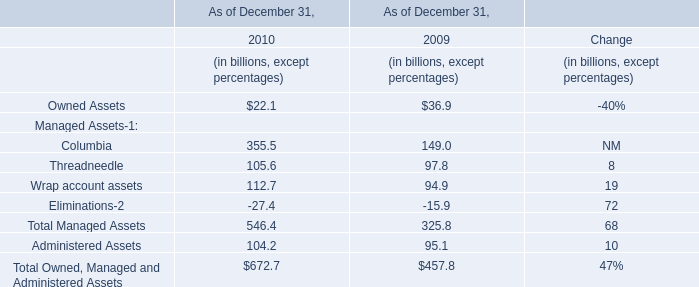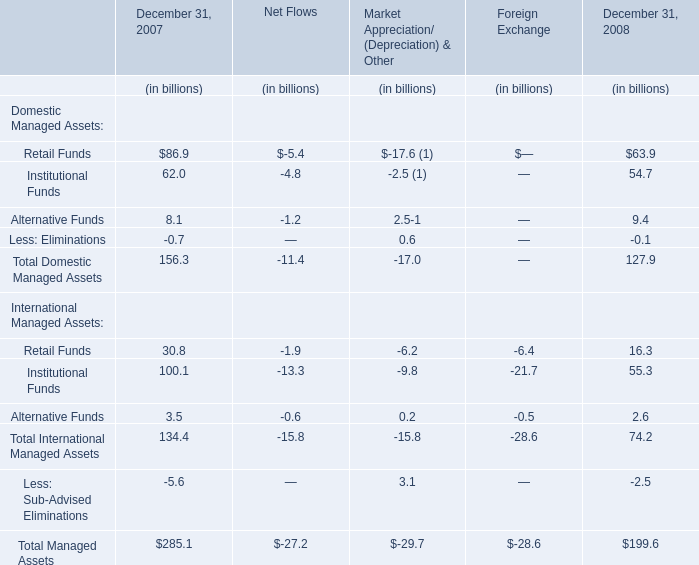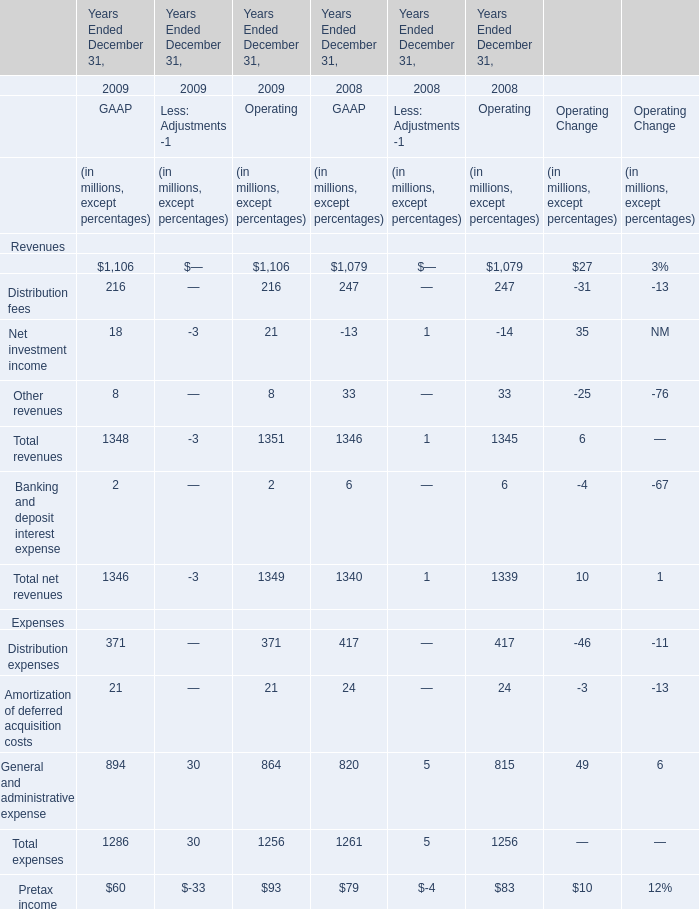What will Total revenues be like in 2010 if it develops with the same increasing rate as current? (in million) 
Computations: (1351 + ((1351 * (1351 - 1345)) / 1345))
Answer: 1357.02677. 